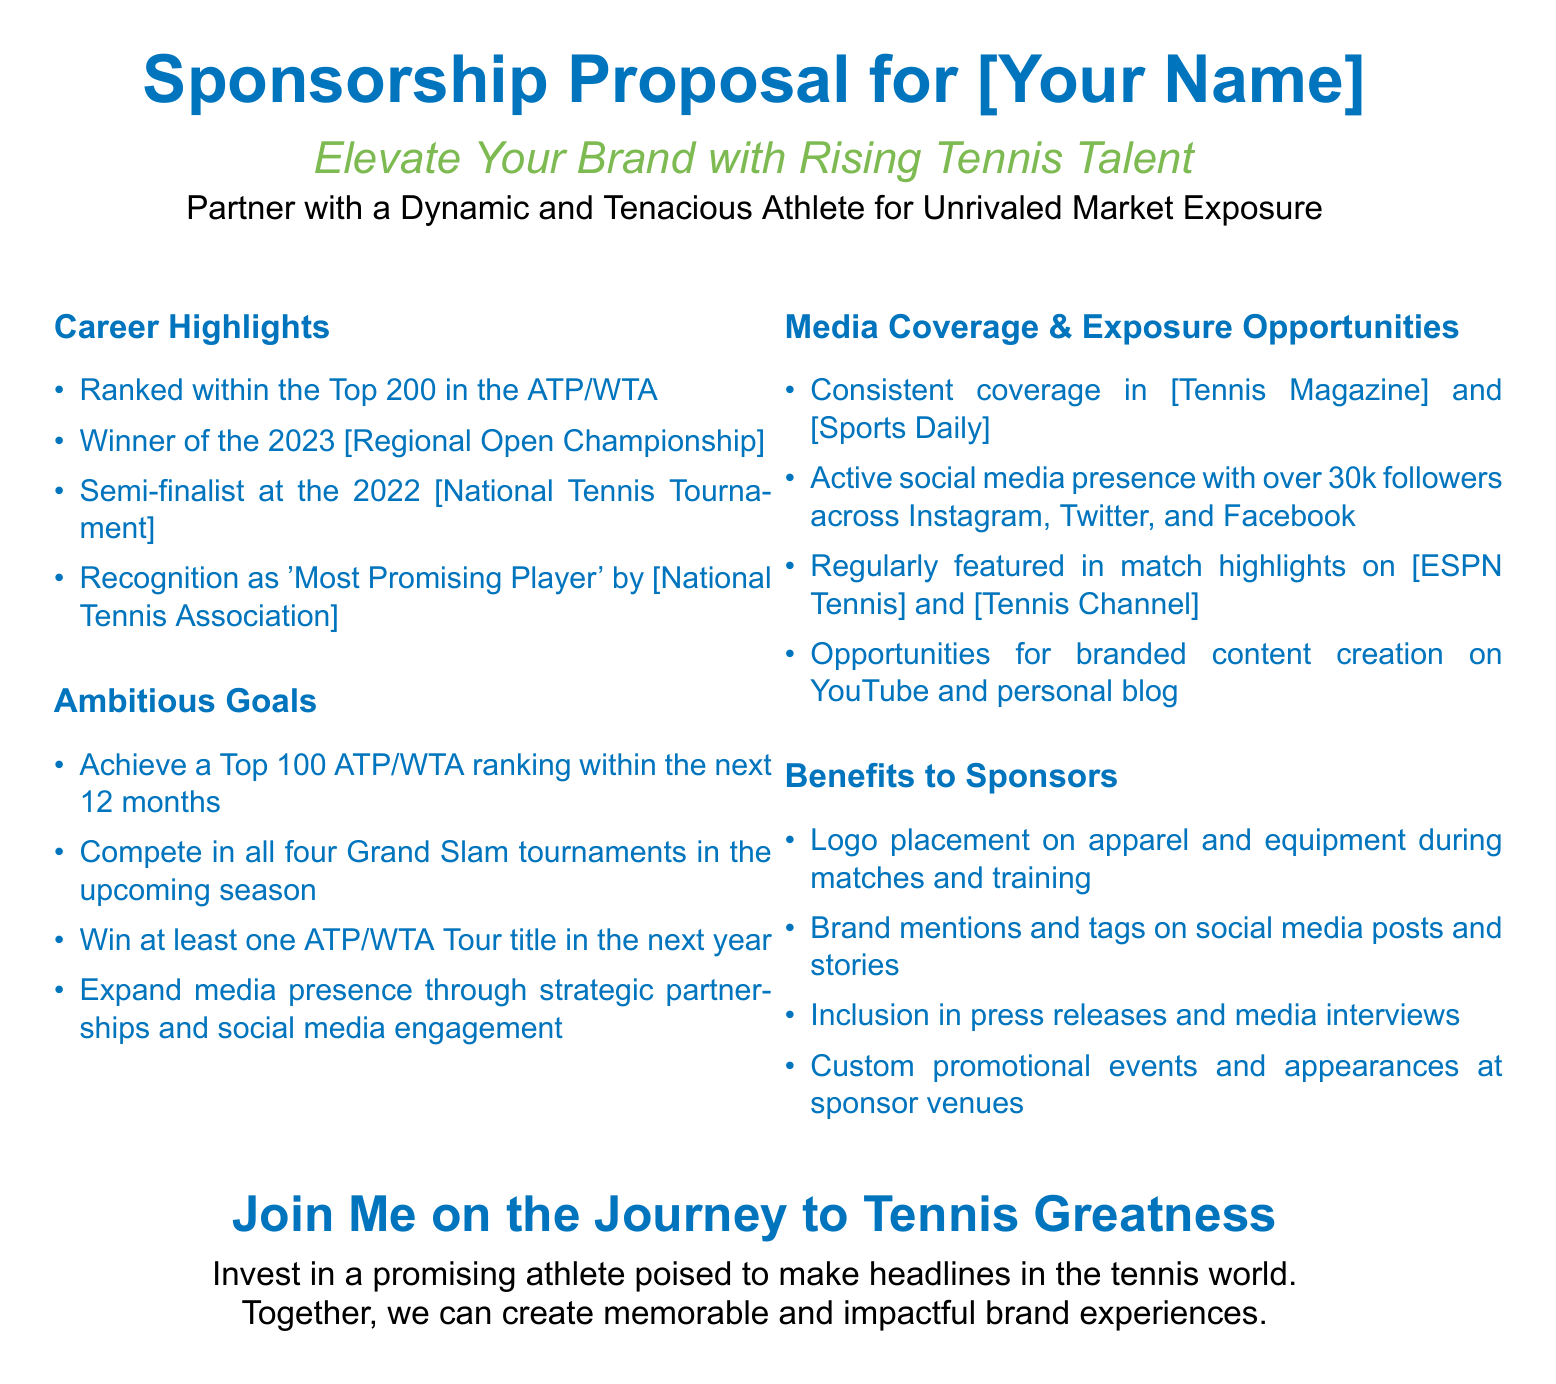What is the highest ATP/WTA ranking achieved? The highest ranking is mentioned in the Career Highlights as being within the Top 200.
Answer: Top 200 What title was won in 2023? The document specifies that the title won is the Regional Open Championship.
Answer: Regional Open Championship What is the goal for ATP/WTA ranking within the next 12 months? The document states the goal is to achieve a Top 100 ATP/WTA ranking.
Answer: Top 100 How many followers are on social media? The document mentions an active social media presence with over 30k followers.
Answer: 30k What is one of the benefits to sponsors? One of the listed benefits to sponsors is logo placement on apparel and equipment.
Answer: Logo placement on apparel and equipment Which media outlets provide coverage? The document highlights coverage in Tennis Magazine and Sports Daily among others.
Answer: Tennis Magazine and Sports Daily What is a goal for media presence expansion? The document states the goal is to expand media presence through strategic partnerships and social media engagement.
Answer: Strategic partnerships and social media engagement What is the title of the proposal? The title of the proposal is "Sponsorship Proposal for [Your Name]."
Answer: Sponsorship Proposal for [Your Name] What type of event is mentioned for sponsor involvement? The document mentions custom promotional events for sponsor venues.
Answer: Custom promotional events 